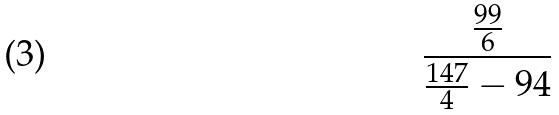<formula> <loc_0><loc_0><loc_500><loc_500>\frac { \frac { 9 9 } { 6 } } { \frac { 1 4 7 } { 4 } - 9 4 }</formula> 